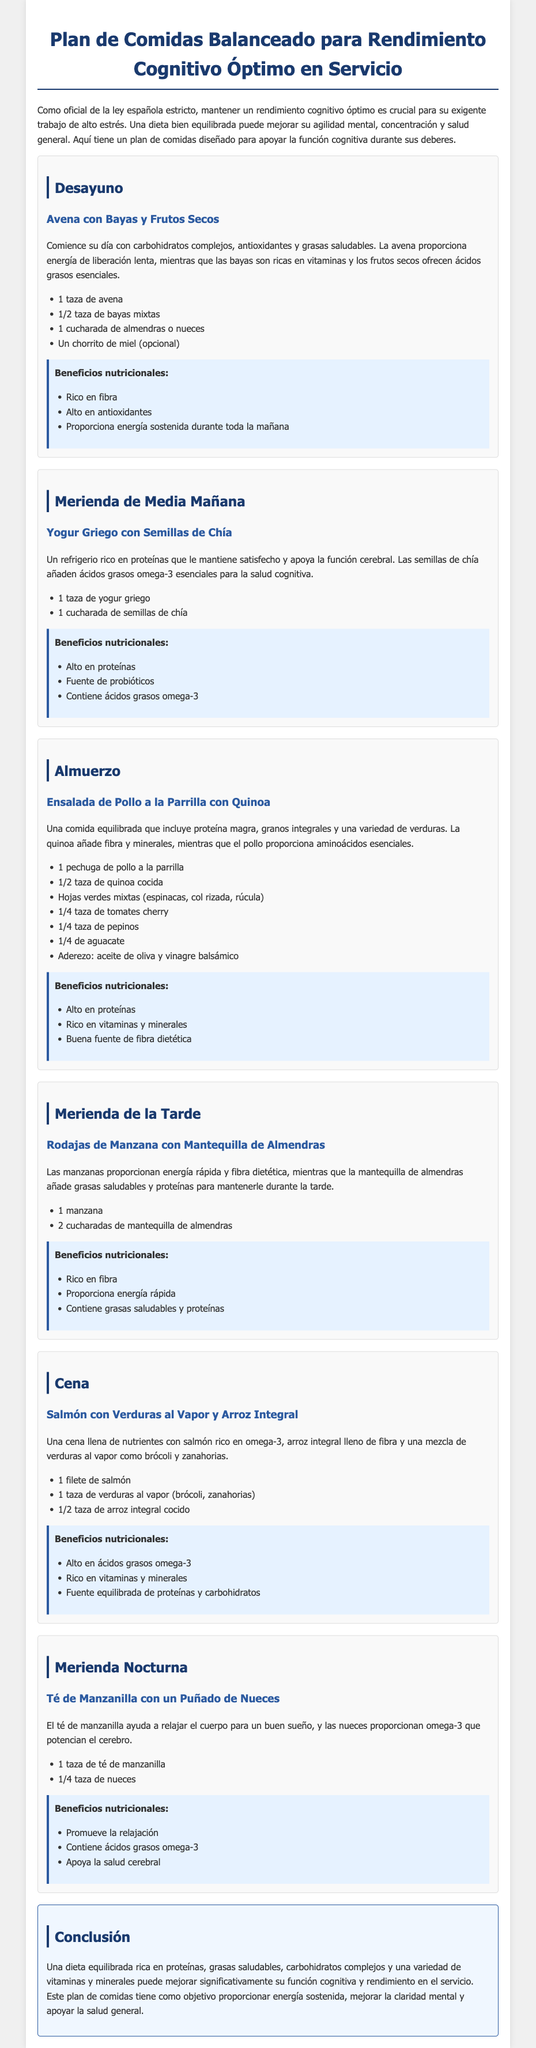¿Cuál es el título del documento? El título del documento, que se menciona en la parte superior, proporciona una visión general de su contenido, que es un plan de comidas para el rendimiento cognitivo.
Answer: Plan de Comidas Balanceado para Rendimiento Cognitivo Óptimo en Servicio ¿Cuál es la primera comida del día en el plan? La primera comida mencionada en el documento es un desayuno diseñado para comenzar el día con energía y nutrientes.
Answer: Desayuno ¿Cuántas cucharadas de mantequilla de almendras se recomienda para la merienda de la tarde? La cantidad especificada en el plan de comidas para esa merienda es fundamental para obtener los nutrientes deseados.
Answer: 2 cucharadas ¿Cuál es uno de los beneficios del yogur griego con semillas de chía? Se menciona en el documento que este refrigerio ofrece beneficios nutricionales específicos que son importantes para el rendimiento cognitivo.
Answer: Alto en proteínas ¿Qué fuente de proteínas se sugiere para la cena? La cena incluye un componente clave que proporciona proteínas esenciales y nutrientes para la salud.
Answer: Salmón ¿Cuántas horas se recomienda tomar el té de manzanilla por la noche? El documento no especifica horas, pero el té de manzanilla es parte de una merienda nocturna que favorece el buen sueño.
Answer: 1 taza ¿Cuáles son los ingredientes de la ensalada de pollo a la parrilla? La ensalada contiene varios ingredientes que se combinan para ofrecer un almuerzo nutritivo y equilibrado.
Answer: Pollo a la parrilla, quinoa, hojas verdes, tomates cherry, pepinos, aguacate ¿Qué tipo de grasas están presentes en la mantequilla de almendras? Se enfatizan las propiedades de las grasas en este alimento específico que se incluye en el plan de merienda.
Answer: Grasas saludables 